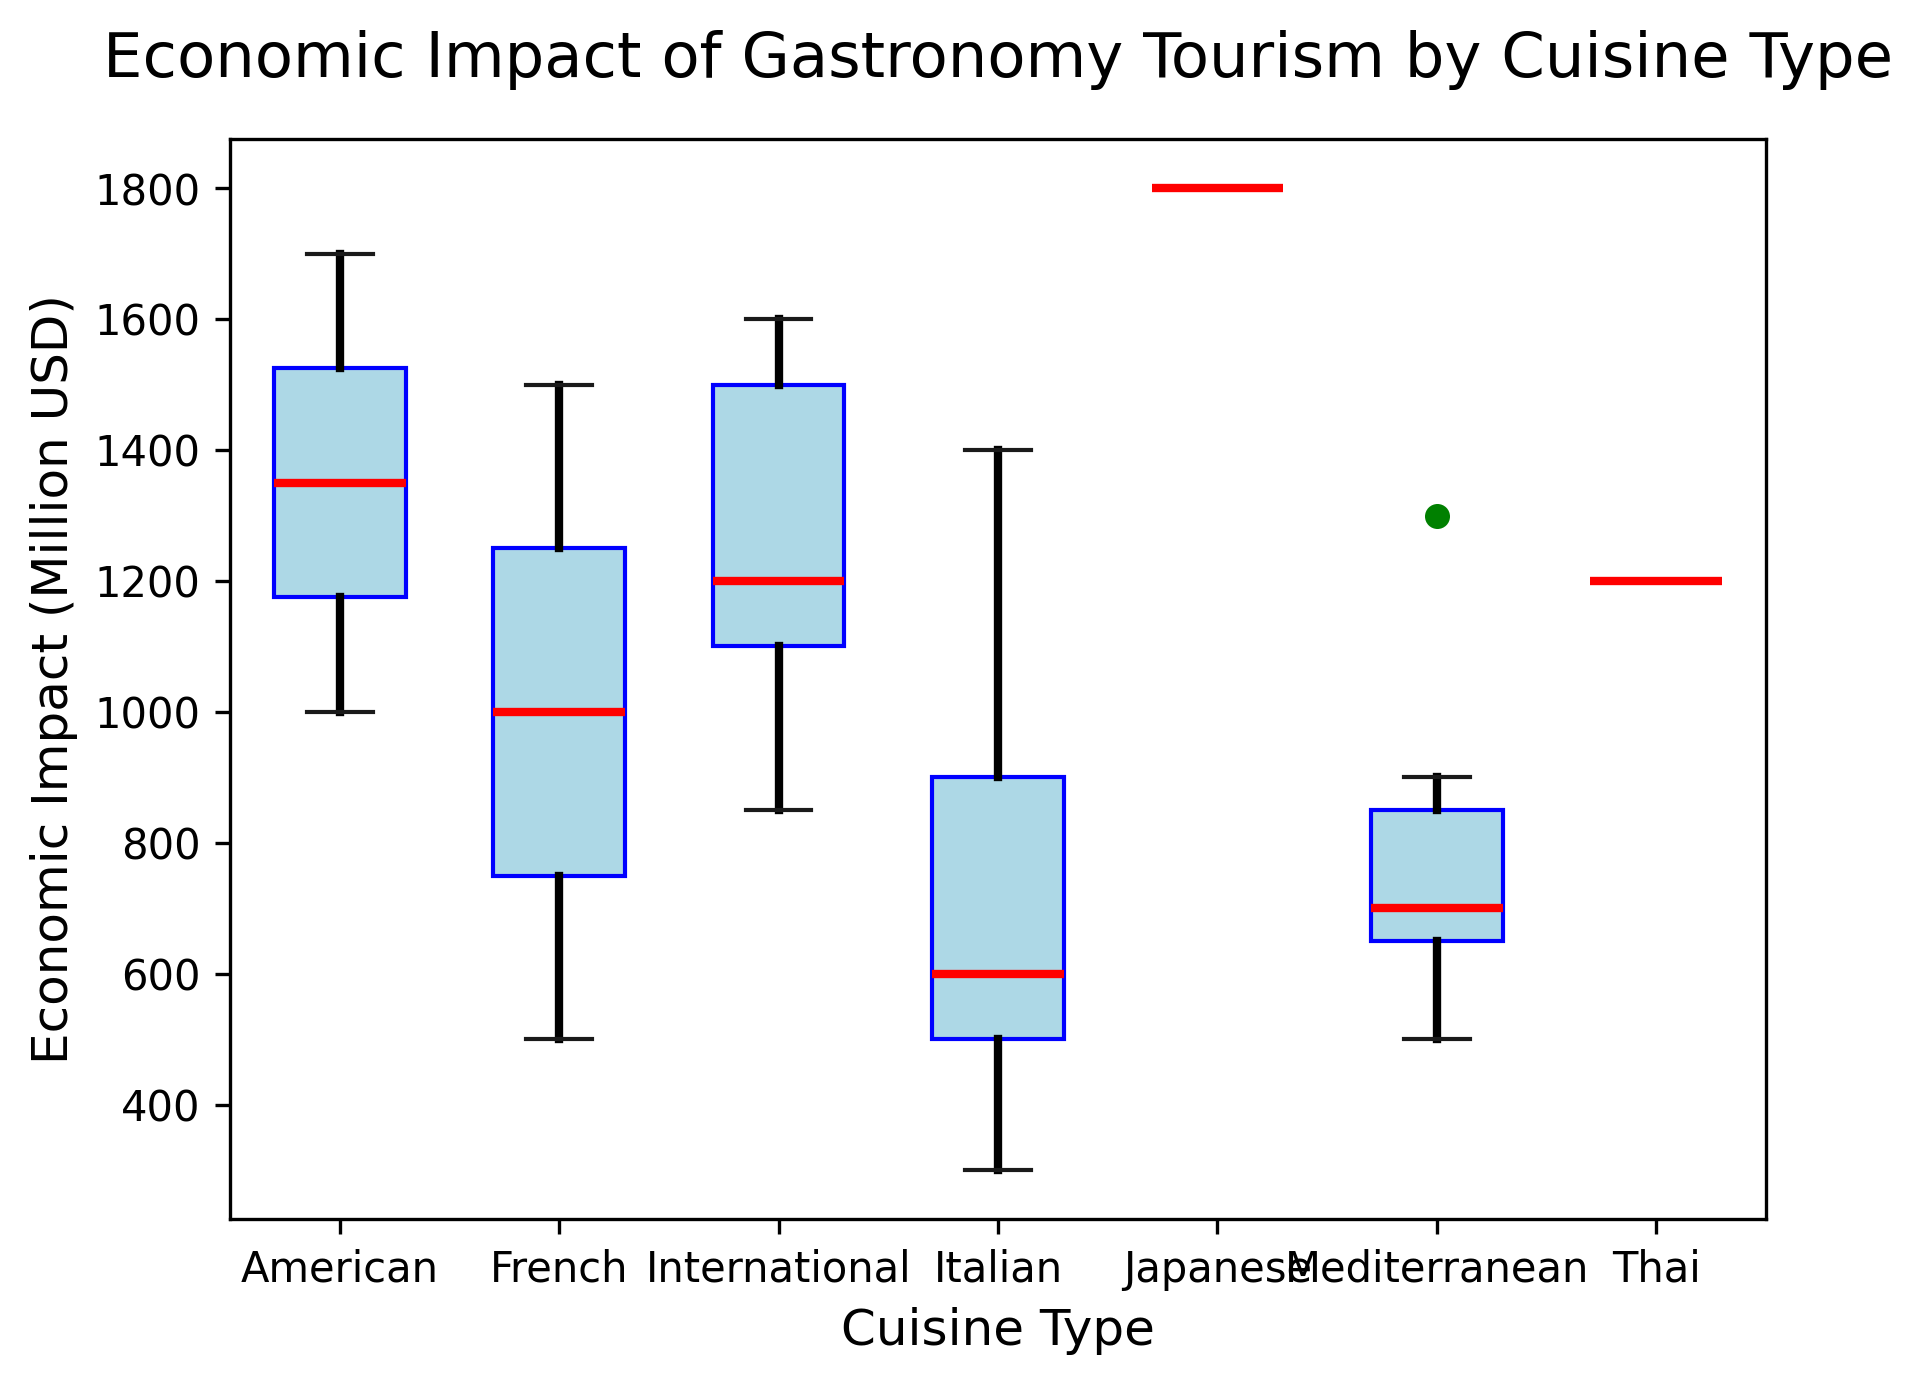what is the cuisine type with the highest median economic impact? To determine the cuisine type with the highest median economic impact, observe the red median lines in each box plot. The cuisine type with the highest median red line corresponds to the highest median economic impact.
Answer: Japanese which city features the most diverse range in economic impact for international cuisines? Inspect the whiskers of the "International" cuisine type for each city. The city with the longest distance between the upper and lower whiskers indicates the widest range.
Answer: Tokyo what is the range of economic impact for Italian cuisine in Rome? To find the range, locate the bottom and top whiskers of the Italian cuisine box plot for Rome. Subtract the value at the bottom whisker from the value at the top whisker.
Answer: 900 (1400-500) compare the maximum economic impact of Mediterranean cuisine across different cities Observe the top whisker of the Mediterranean cuisine box plot for each city, noting the highest points each reaches.
Answer: Barcelona has the highest are there any cuisine types where the economic impact is consistently low across all cities? Look for cuisine types where all their box plots across cities have low median and low upper whisker values.
Answer: Italian and Mediterranean demonstrate consistently lower impacts which cuisine in Paris has the lowest economic impact? Examine the Paris box plots, and identify the smallest bottom whisker value across all cuisine types.
Answer: Mediterranean how does the variability of international cuisine economic impact in Sydney compare to New York? Compare the spread of the box plots for "International" cuisine type in both cities by noting the range between the top and bottom whiskers.
Answer: New York has higher variability which two cuisine types have similar median economic impacts? Identify the cuisine types by comparing the red median lines across the different box plots, looking for similar levels.
Answer: Mediterranean and Italian 